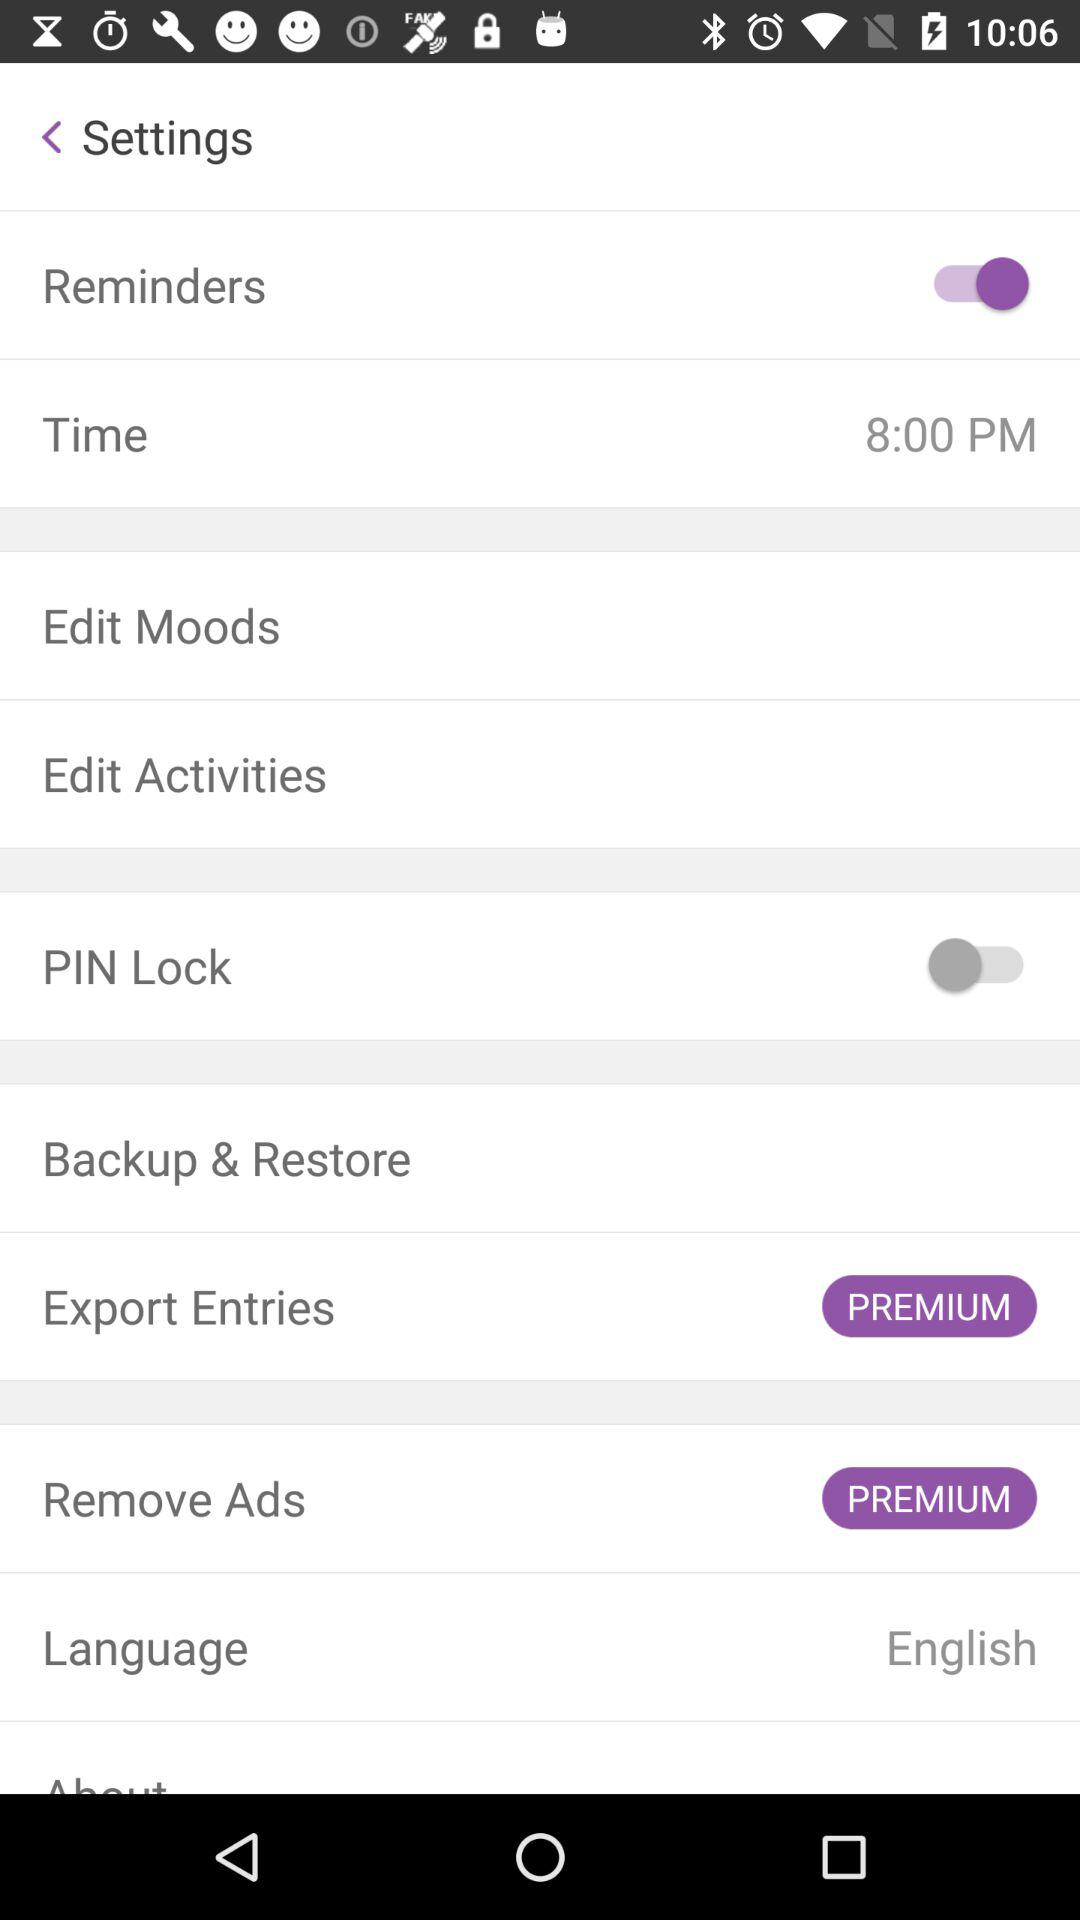What is the selected language? The selected language is English. 